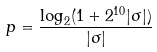<formula> <loc_0><loc_0><loc_500><loc_500>p = \frac { \log _ { 2 } ( 1 + 2 ^ { 1 0 } | \sigma | ) } { | \sigma | }</formula> 